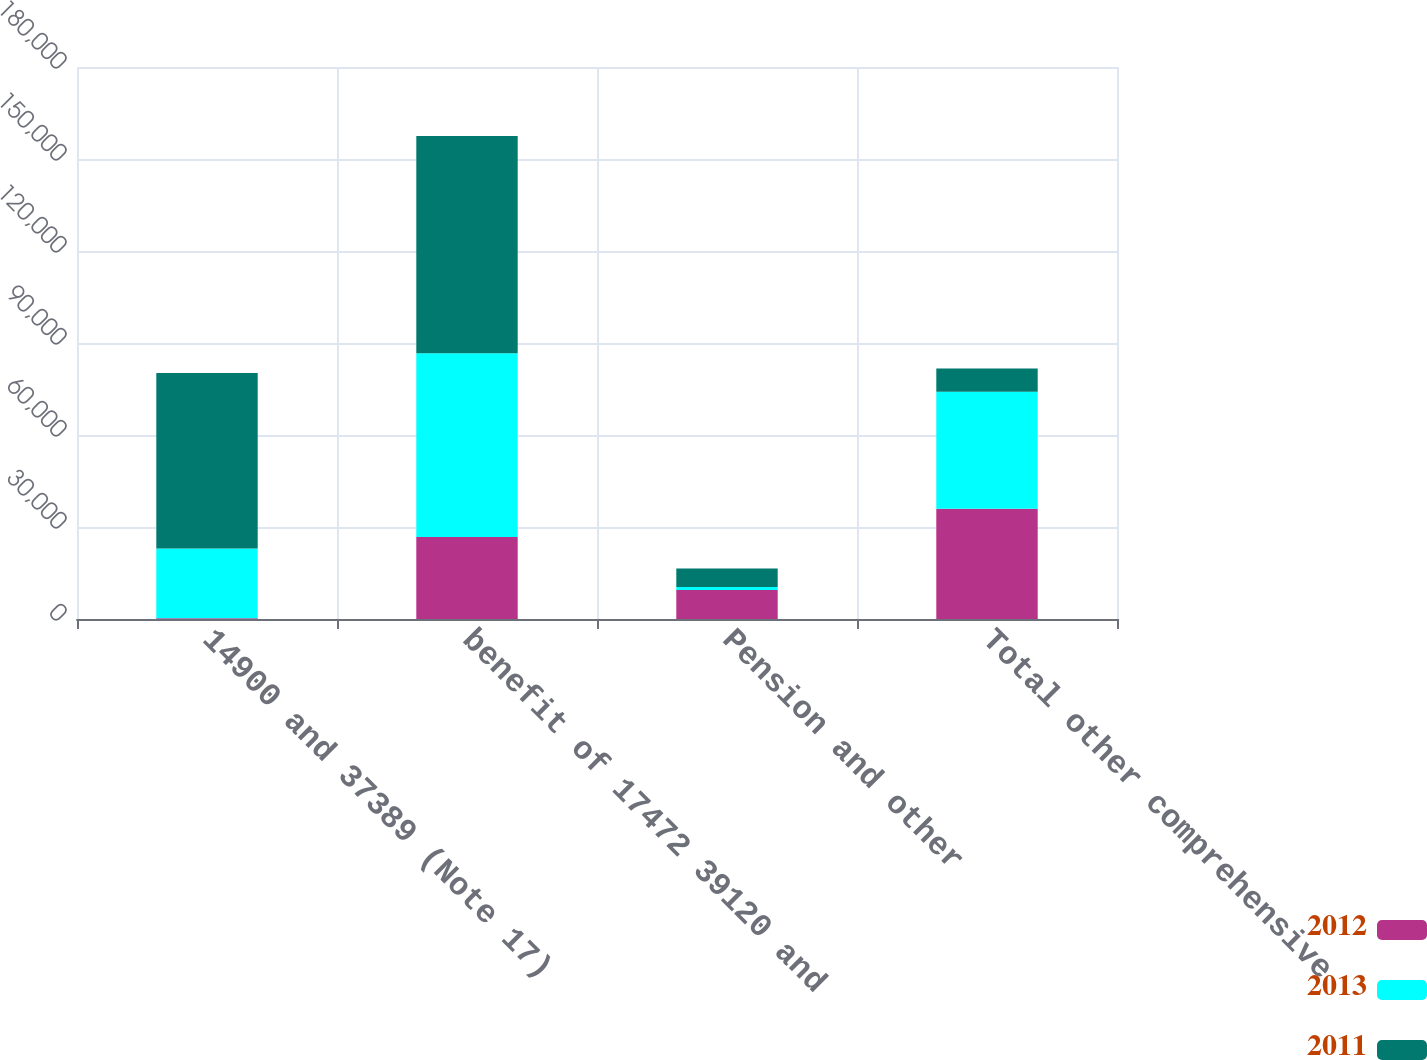<chart> <loc_0><loc_0><loc_500><loc_500><stacked_bar_chart><ecel><fcel>14900 and 37389 (Note 17)<fcel>benefit of 17472 39120 and<fcel>Pension and other<fcel>Total other comprehensive<nl><fcel>2012<fcel>213<fcel>26747<fcel>9421<fcel>35955<nl><fcel>2013<fcel>22763<fcel>59887<fcel>1031<fcel>38155<nl><fcel>2011<fcel>57271<fcel>70902<fcel>6026<fcel>7605<nl></chart> 